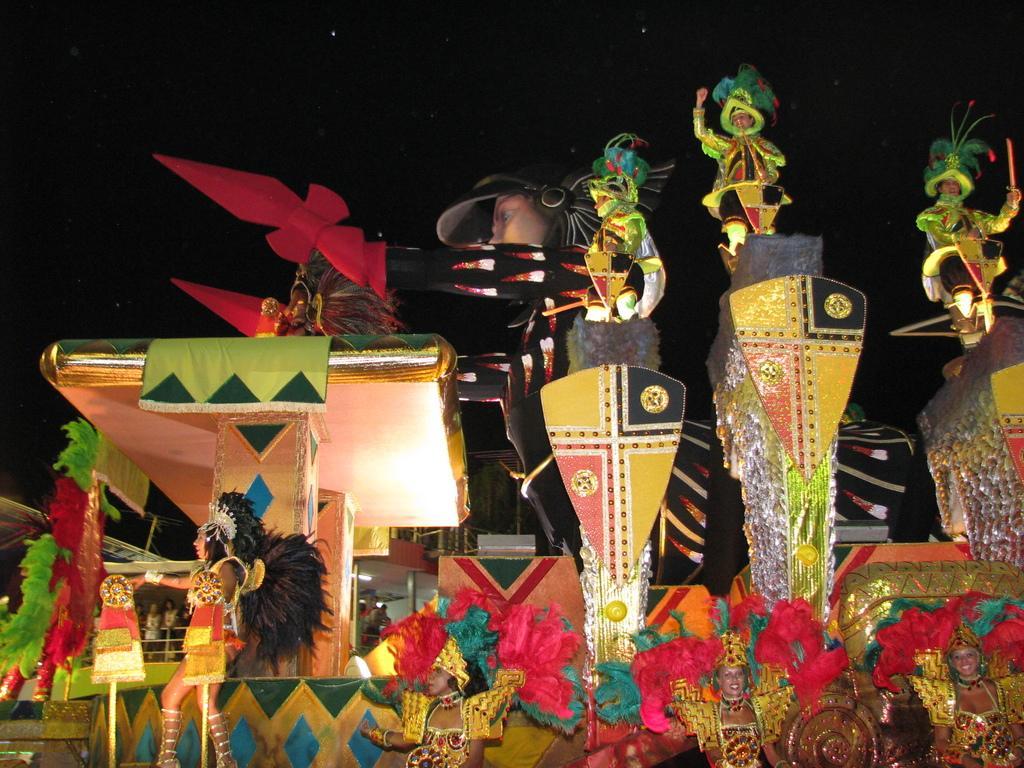Could you give a brief overview of what you see in this image? This is an image clicked in the dark. This is looking like a stage which is decorated with the multi color clothes, boards. At the bottom of the image I can see a few people are wearing costumes and dancing. Here I can see few pillars. On the pillars there are people standing and it is looking like they are dancing. At the top of the image I can see the sky along with the stars. 